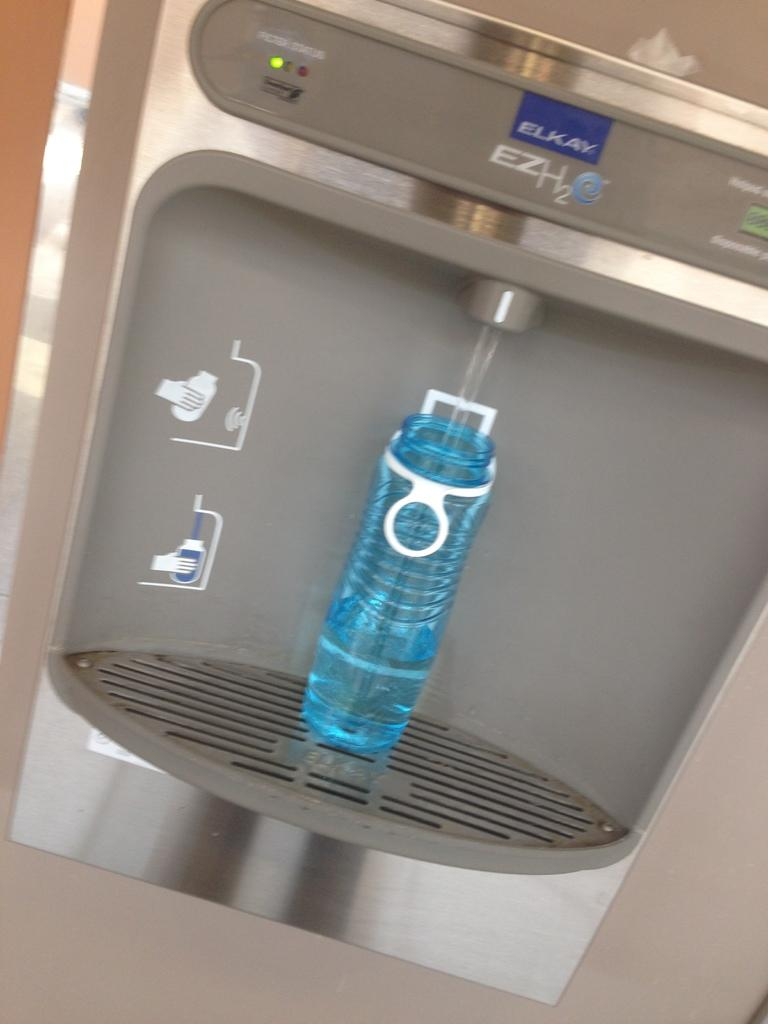What object can be seen in the image related to hydration? There is a water bottle in the image. What color is the water bottle? The water bottle is blue. What type of pancake is being served on the blue plate in the image? There is no blue plate or pancake present in the image; it only features a blue water bottle. 